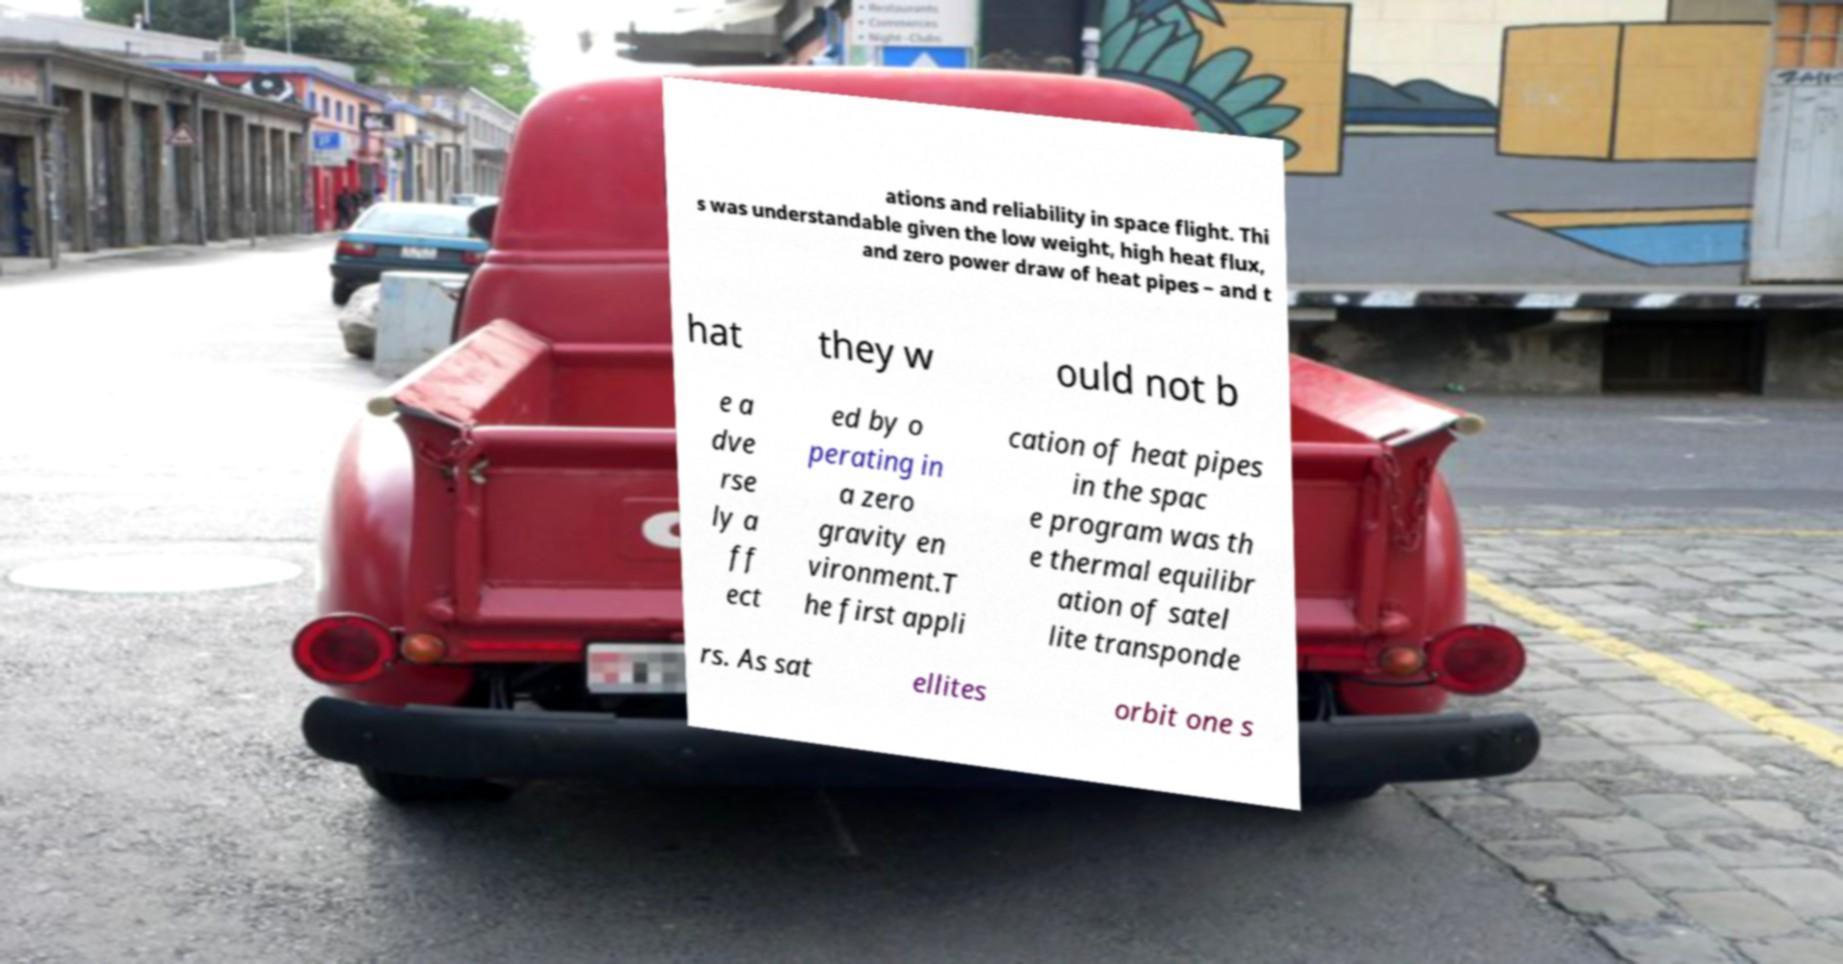What messages or text are displayed in this image? I need them in a readable, typed format. ations and reliability in space flight. Thi s was understandable given the low weight, high heat flux, and zero power draw of heat pipes – and t hat they w ould not b e a dve rse ly a ff ect ed by o perating in a zero gravity en vironment.T he first appli cation of heat pipes in the spac e program was th e thermal equilibr ation of satel lite transponde rs. As sat ellites orbit one s 